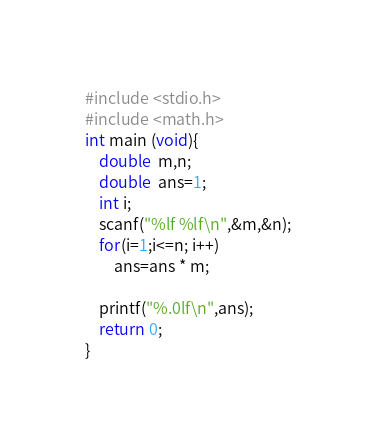<code> <loc_0><loc_0><loc_500><loc_500><_C_>#include <stdio.h>
#include <math.h>
int main (void){
	double  m,n;
	double  ans=1;
	int i;
	scanf("%lf %lf\n",&m,&n);
	for(i=1;i<=n; i++)
		ans=ans * m;
	
	printf("%.0lf\n",ans);
 	return 0;
}
</code> 